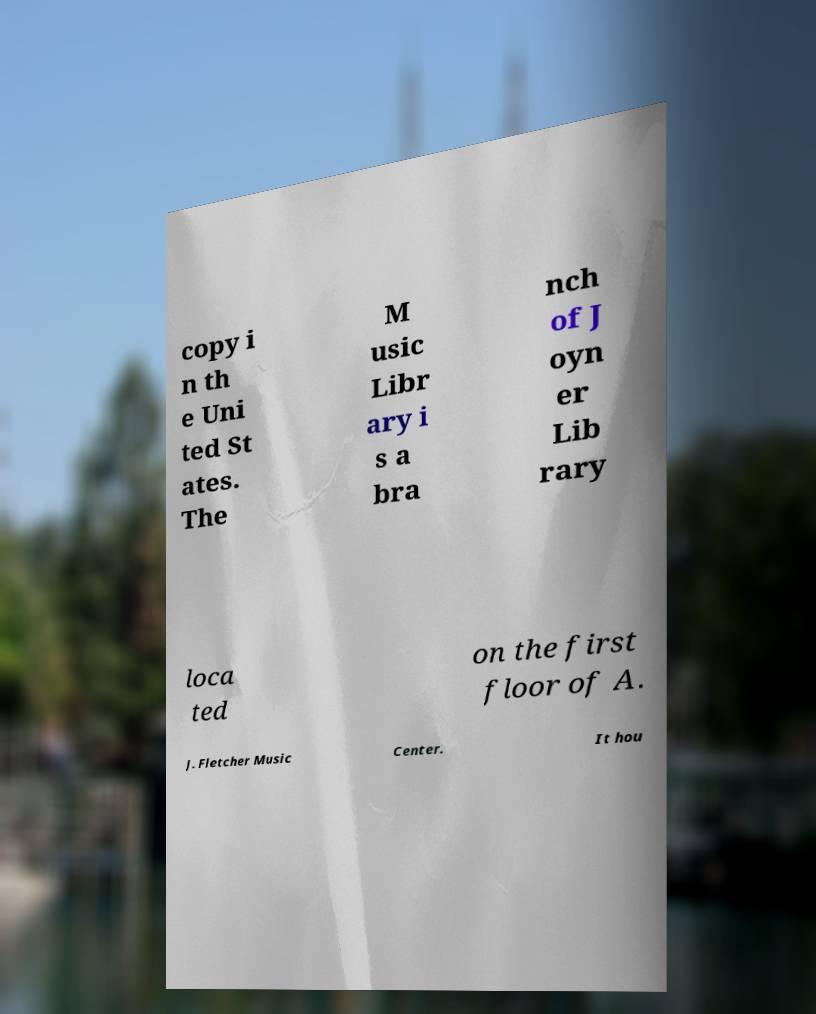Could you assist in decoding the text presented in this image and type it out clearly? copy i n th e Uni ted St ates. The M usic Libr ary i s a bra nch of J oyn er Lib rary loca ted on the first floor of A. J. Fletcher Music Center. It hou 